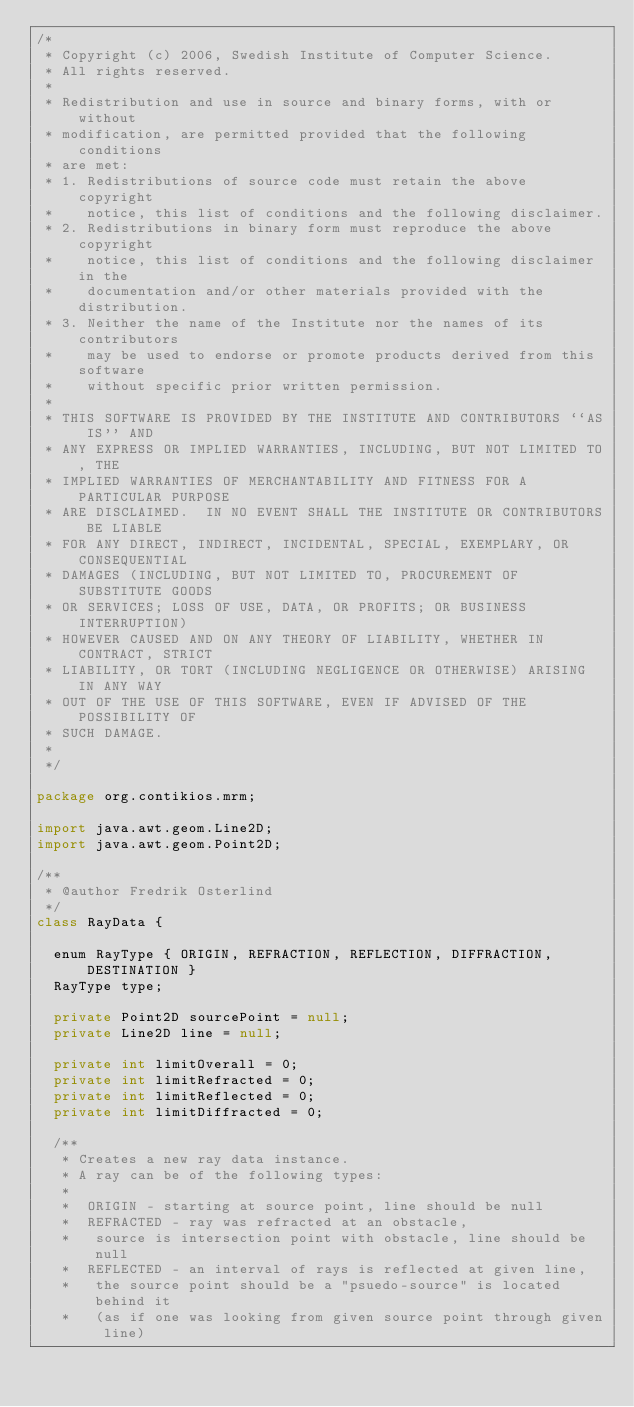<code> <loc_0><loc_0><loc_500><loc_500><_Java_>/*
 * Copyright (c) 2006, Swedish Institute of Computer Science.
 * All rights reserved.
 *
 * Redistribution and use in source and binary forms, with or without
 * modification, are permitted provided that the following conditions
 * are met:
 * 1. Redistributions of source code must retain the above copyright
 *    notice, this list of conditions and the following disclaimer.
 * 2. Redistributions in binary form must reproduce the above copyright
 *    notice, this list of conditions and the following disclaimer in the
 *    documentation and/or other materials provided with the distribution.
 * 3. Neither the name of the Institute nor the names of its contributors
 *    may be used to endorse or promote products derived from this software
 *    without specific prior written permission.
 *
 * THIS SOFTWARE IS PROVIDED BY THE INSTITUTE AND CONTRIBUTORS ``AS IS'' AND
 * ANY EXPRESS OR IMPLIED WARRANTIES, INCLUDING, BUT NOT LIMITED TO, THE
 * IMPLIED WARRANTIES OF MERCHANTABILITY AND FITNESS FOR A PARTICULAR PURPOSE
 * ARE DISCLAIMED.  IN NO EVENT SHALL THE INSTITUTE OR CONTRIBUTORS BE LIABLE
 * FOR ANY DIRECT, INDIRECT, INCIDENTAL, SPECIAL, EXEMPLARY, OR CONSEQUENTIAL
 * DAMAGES (INCLUDING, BUT NOT LIMITED TO, PROCUREMENT OF SUBSTITUTE GOODS
 * OR SERVICES; LOSS OF USE, DATA, OR PROFITS; OR BUSINESS INTERRUPTION)
 * HOWEVER CAUSED AND ON ANY THEORY OF LIABILITY, WHETHER IN CONTRACT, STRICT
 * LIABILITY, OR TORT (INCLUDING NEGLIGENCE OR OTHERWISE) ARISING IN ANY WAY
 * OUT OF THE USE OF THIS SOFTWARE, EVEN IF ADVISED OF THE POSSIBILITY OF
 * SUCH DAMAGE.
 *
 */

package org.contikios.mrm;

import java.awt.geom.Line2D;
import java.awt.geom.Point2D;

/**
 * @author Fredrik Osterlind
 */
class RayData {
  
  enum RayType { ORIGIN, REFRACTION, REFLECTION, DIFFRACTION, DESTINATION }
  RayType type;
  
  private Point2D sourcePoint = null;
  private Line2D line = null;

  private int limitOverall = 0;
  private int limitRefracted = 0;
  private int limitReflected = 0;
  private int limitDiffracted = 0;

  /**
   * Creates a new ray data instance.
   * A ray can be of the following types:
   * 
   *  ORIGIN - starting at source point, line should be null
   *  REFRACTED - ray was refracted at an obstacle, 
   *   source is intersection point with obstacle, line should be null
   *  REFLECTED - an interval of rays is reflected at given line,
   *   the source point should be a "psuedo-source" is located behind it
   *   (as if one was looking from given source point through given line)</code> 